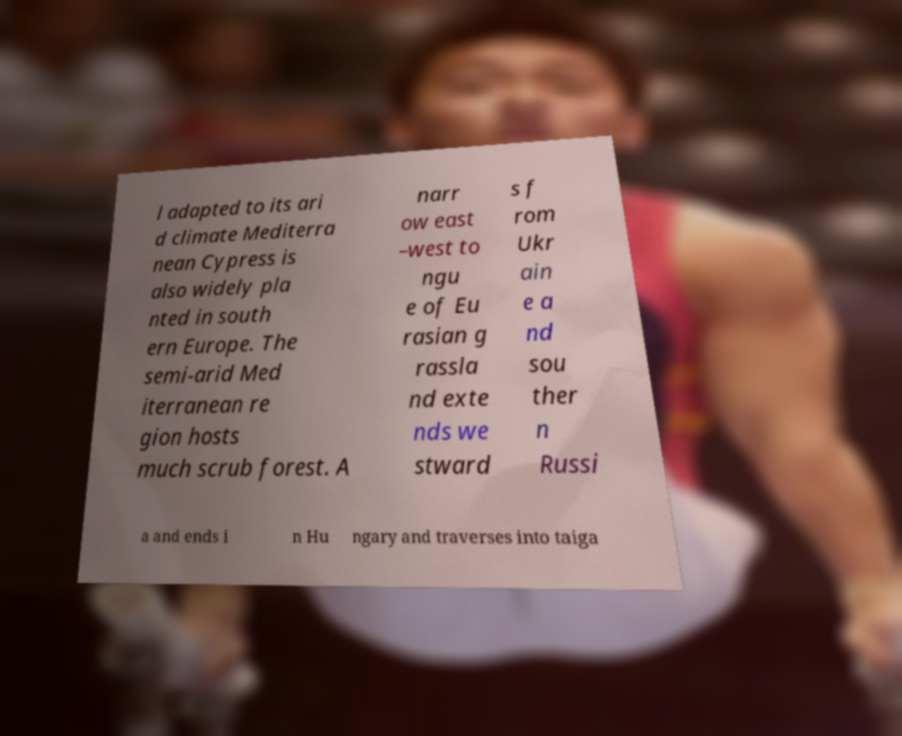Can you accurately transcribe the text from the provided image for me? l adapted to its ari d climate Mediterra nean Cypress is also widely pla nted in south ern Europe. The semi-arid Med iterranean re gion hosts much scrub forest. A narr ow east –west to ngu e of Eu rasian g rassla nd exte nds we stward s f rom Ukr ain e a nd sou ther n Russi a and ends i n Hu ngary and traverses into taiga 